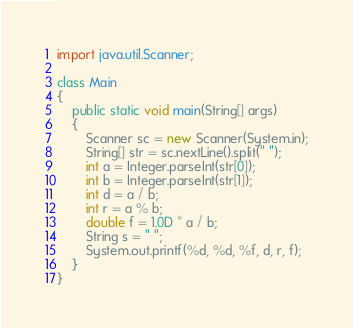<code> <loc_0><loc_0><loc_500><loc_500><_Java_>import java.util.Scanner;

class Main
{
	public static void main(String[] args)
	{
		Scanner sc = new Scanner(System.in);
		String[] str = sc.nextLine().split(" ");
		int a = Integer.parseInt(str[0]);
		int b = Integer.parseInt(str[1]);
		int d = a / b;
		int r = a % b;
		double f = 1.0D * a / b;
		String s = " ";
		System.out.printf(%d, %d, %f, d, r, f);
	}
}</code> 